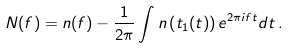Convert formula to latex. <formula><loc_0><loc_0><loc_500><loc_500>N ( f ) = n ( f ) - \frac { 1 } { 2 \pi } \int n \left ( t _ { 1 } ( t ) \right ) e ^ { 2 \pi i f t } d t \, .</formula> 